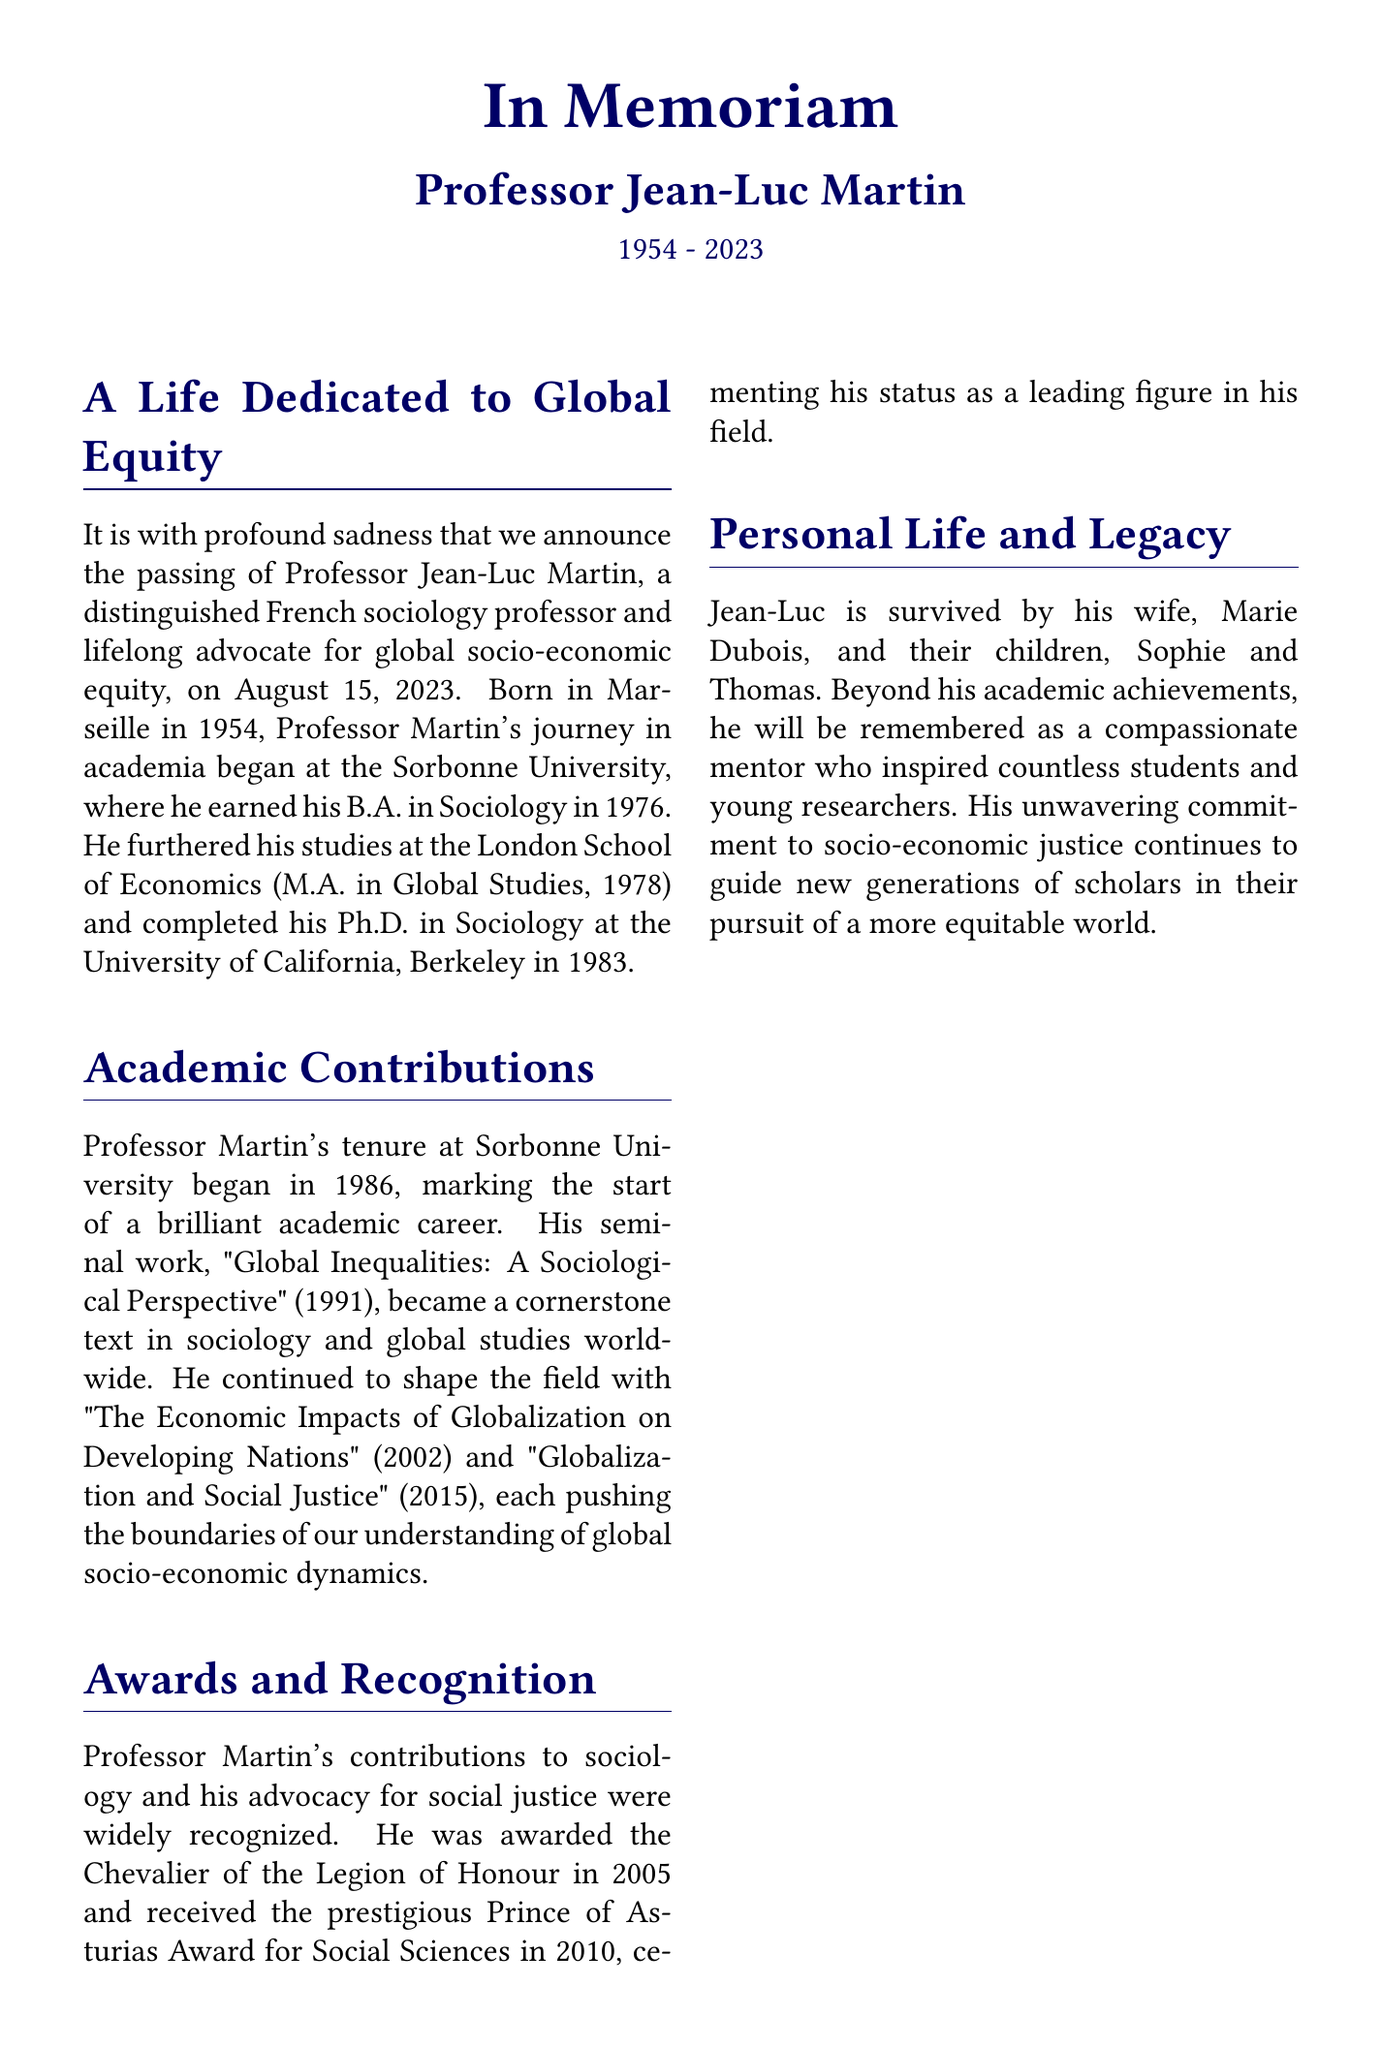What year was Professor Jean-Luc Martin born? The document states that he was born in 1954.
Answer: 1954 What is the title of Professor Martin's seminal work? The obituary mentions "Global Inequalities: A Sociological Perspective" as his seminal work.
Answer: Global Inequalities: A Sociological Perspective Which prestigious award did he receive in 2010? The document indicates he received the Prince of Asturias Award for Social Sciences in 2010.
Answer: Prince of Asturias Award for Social Sciences How many children did Professor Martin have? The text states he is survived by two children, Sophie and Thomas.
Answer: Two What moral imperative did Professor Martin emphasize in his quote? He expressed that the quest for global equity is a moral imperative for our time.
Answer: A moral imperative for our time In which year did Professor Martin pass away? The obituary notes that he passed away on August 15, 2023.
Answer: 2023 What university did Professor Martin attend for his Ph.D.? The document states that he completed his Ph.D. at the University of California, Berkeley.
Answer: University of California, Berkeley What role did Professor Martin have at Sorbonne University beginning in 1986? The document mentions that he began his tenure at Sorbonne University in 1986, marking the start of his academic career.
Answer: Tenure at Sorbonne University What was the focus of Professor Martin's research? His research focused on global socio-economic dynamics and justice.
Answer: Global socio-economic dynamics and justice 